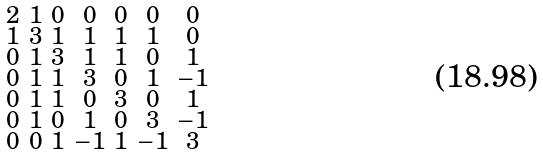Convert formula to latex. <formula><loc_0><loc_0><loc_500><loc_500>\begin{smallmatrix} 2 & 1 & 0 & 0 & 0 & 0 & 0 \\ 1 & 3 & 1 & 1 & 1 & 1 & 0 \\ 0 & 1 & 3 & 1 & 1 & 0 & 1 \\ 0 & 1 & 1 & 3 & 0 & 1 & - 1 \\ 0 & 1 & 1 & 0 & 3 & 0 & 1 \\ 0 & 1 & 0 & 1 & 0 & 3 & - 1 \\ 0 & 0 & 1 & - 1 & 1 & - 1 & 3 \end{smallmatrix}</formula> 